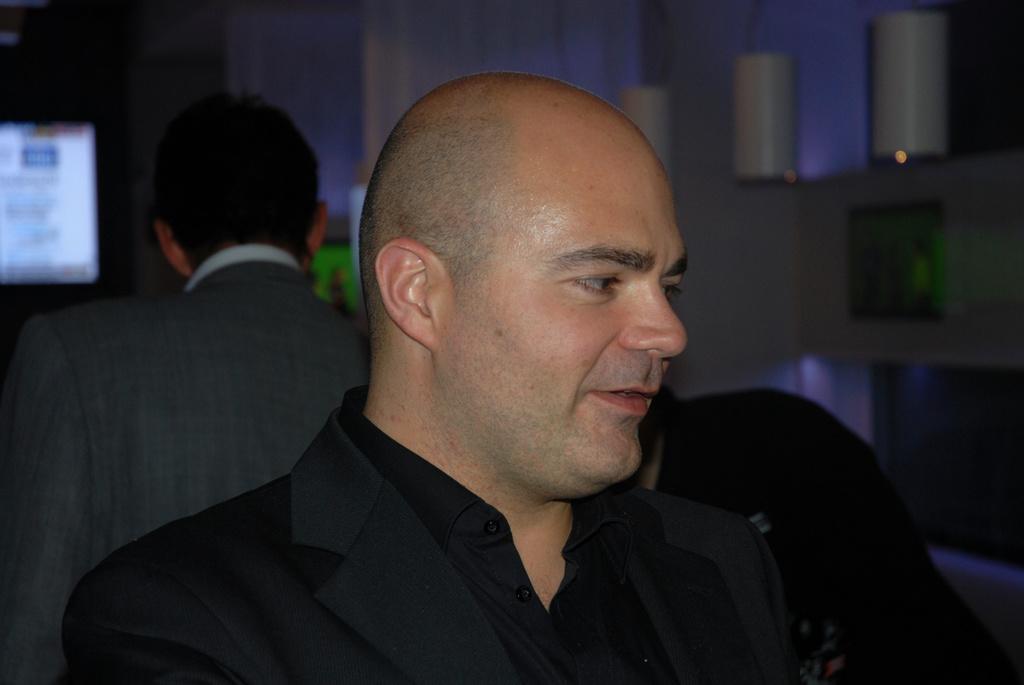How would you summarize this image in a sentence or two? In this image there is a man in black costume standing, behind him there is another man standing and also there is a TV screen. 